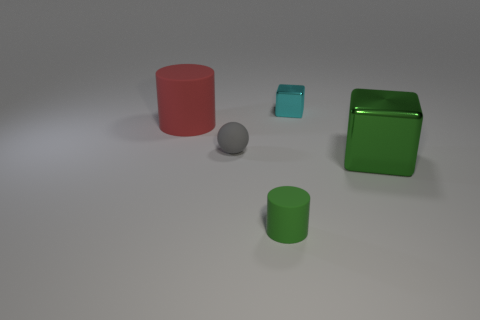There is a metallic object in front of the tiny object behind the rubber object behind the small rubber ball; what shape is it?
Your answer should be compact. Cube. What number of other objects are the same color as the large cylinder?
Make the answer very short. 0. Is the number of things to the right of the red matte thing greater than the number of big green objects behind the big shiny block?
Your response must be concise. Yes. Are there any cyan metallic things in front of the tiny gray matte object?
Make the answer very short. No. The tiny object that is behind the tiny green rubber cylinder and left of the cyan object is made of what material?
Ensure brevity in your answer.  Rubber. What color is the other metallic object that is the same shape as the green metal object?
Provide a succinct answer. Cyan. Is there a small matte thing that is in front of the tiny object left of the tiny matte cylinder?
Your response must be concise. Yes. What is the size of the green metallic thing?
Provide a short and direct response. Large. There is a tiny object that is both right of the matte sphere and left of the tiny metallic thing; what shape is it?
Ensure brevity in your answer.  Cylinder. What number of cyan things are tiny rubber things or cubes?
Provide a succinct answer. 1. 